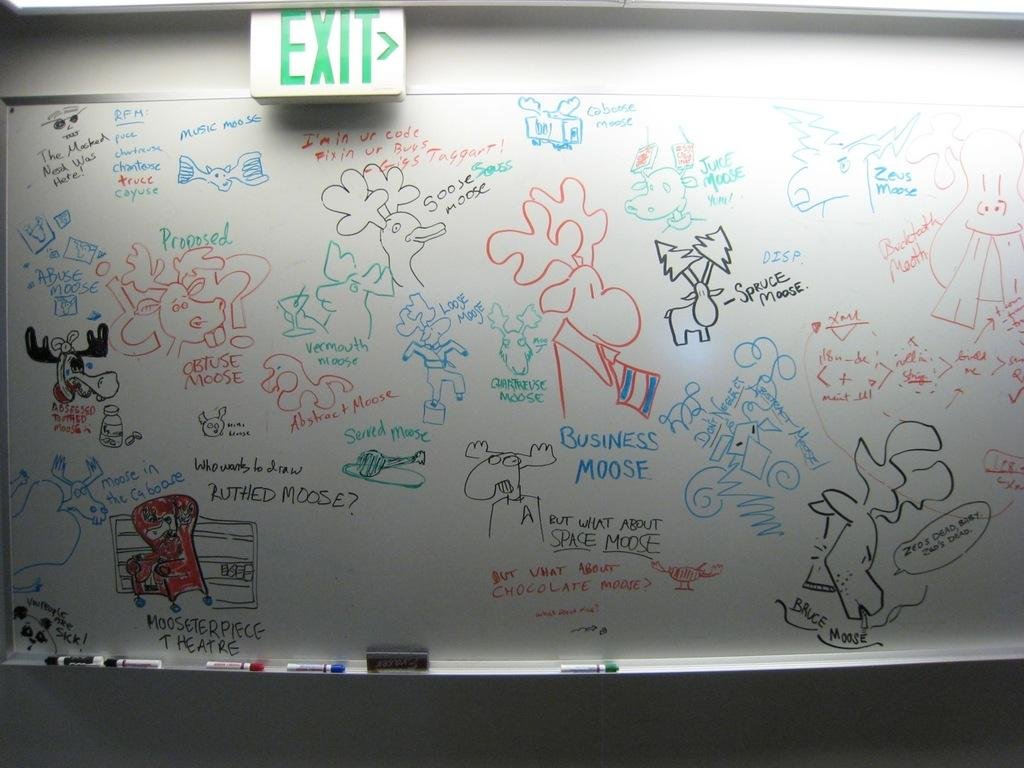<image>
Write a terse but informative summary of the picture. BUT WHAT ABOUT SPACE MOOSE is written amongst a bunch of words on a whiteboard. 